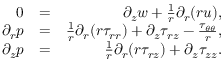Convert formula to latex. <formula><loc_0><loc_0><loc_500><loc_500>\begin{array} { r l r } { 0 } & { = } & { \partial _ { z } { w } + \frac { 1 } { r } \partial _ { r } ( r { u } ) , } \\ { \partial _ { r } { p } } & { = } & { \frac { 1 } { r } \partial _ { r } ( r \tau _ { r r } ) + \partial _ { z } \tau _ { r z } - \frac { \tau _ { \theta \theta } } { r } , } \\ { \partial _ { z } { p } } & { = } & { \frac { 1 } { r } \partial _ { r } ( r \tau _ { r z } ) + \partial _ { z } \tau _ { z z } . } \end{array}</formula> 